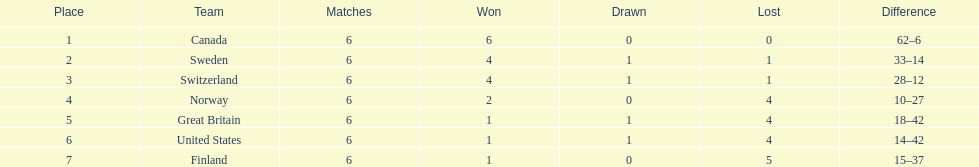Which country's team came in last place during the 1951 world ice hockey championships? Finland. 